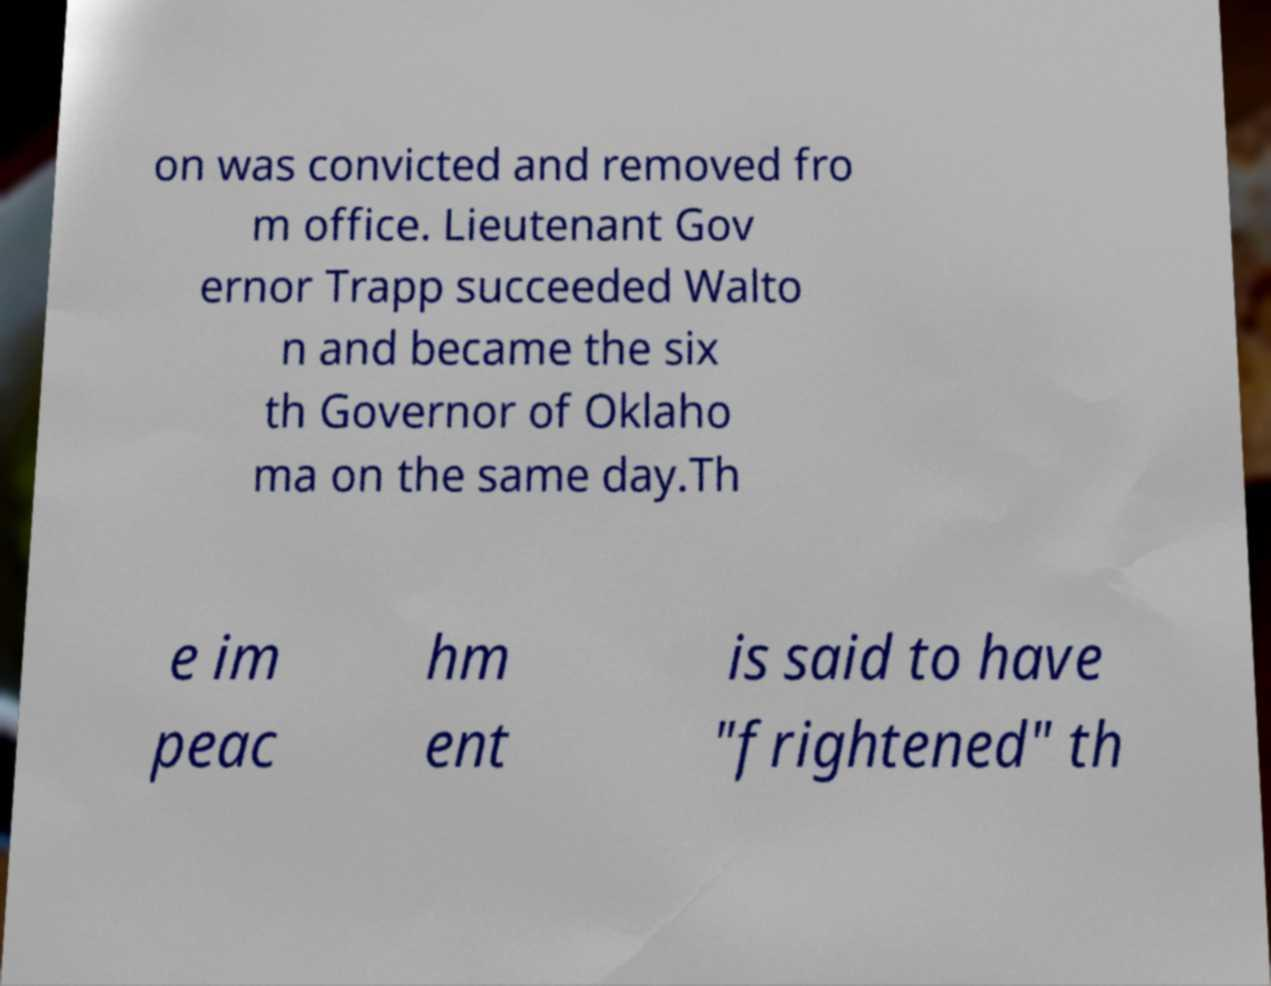Please read and relay the text visible in this image. What does it say? on was convicted and removed fro m office. Lieutenant Gov ernor Trapp succeeded Walto n and became the six th Governor of Oklaho ma on the same day.Th e im peac hm ent is said to have "frightened" th 